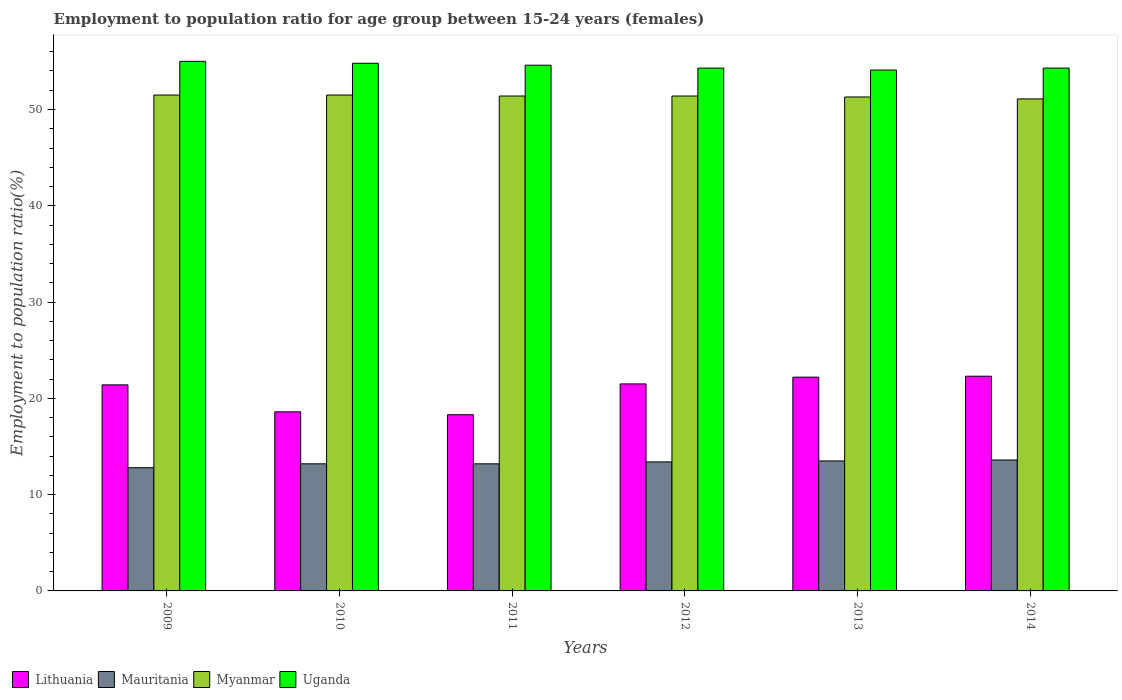How many groups of bars are there?
Make the answer very short. 6. Are the number of bars per tick equal to the number of legend labels?
Offer a terse response. Yes. Are the number of bars on each tick of the X-axis equal?
Your answer should be very brief. Yes. What is the employment to population ratio in Myanmar in 2013?
Keep it short and to the point. 51.3. Across all years, what is the maximum employment to population ratio in Myanmar?
Your response must be concise. 51.5. Across all years, what is the minimum employment to population ratio in Lithuania?
Offer a very short reply. 18.3. In which year was the employment to population ratio in Lithuania maximum?
Offer a very short reply. 2014. In which year was the employment to population ratio in Uganda minimum?
Keep it short and to the point. 2013. What is the total employment to population ratio in Uganda in the graph?
Offer a very short reply. 327.1. What is the difference between the employment to population ratio in Lithuania in 2010 and that in 2012?
Your response must be concise. -2.9. What is the difference between the employment to population ratio in Uganda in 2011 and the employment to population ratio in Myanmar in 2012?
Provide a short and direct response. 3.2. What is the average employment to population ratio in Myanmar per year?
Give a very brief answer. 51.37. In the year 2014, what is the difference between the employment to population ratio in Mauritania and employment to population ratio in Myanmar?
Keep it short and to the point. -37.5. What is the ratio of the employment to population ratio in Uganda in 2010 to that in 2011?
Make the answer very short. 1. Is the employment to population ratio in Lithuania in 2009 less than that in 2010?
Your answer should be very brief. No. Is the difference between the employment to population ratio in Mauritania in 2011 and 2014 greater than the difference between the employment to population ratio in Myanmar in 2011 and 2014?
Ensure brevity in your answer.  No. What is the difference between the highest and the lowest employment to population ratio in Myanmar?
Your answer should be very brief. 0.4. In how many years, is the employment to population ratio in Uganda greater than the average employment to population ratio in Uganda taken over all years?
Give a very brief answer. 3. What does the 1st bar from the left in 2012 represents?
Give a very brief answer. Lithuania. What does the 2nd bar from the right in 2010 represents?
Keep it short and to the point. Myanmar. How many bars are there?
Your answer should be compact. 24. What is the difference between two consecutive major ticks on the Y-axis?
Make the answer very short. 10. Does the graph contain any zero values?
Your answer should be compact. No. Where does the legend appear in the graph?
Make the answer very short. Bottom left. How many legend labels are there?
Make the answer very short. 4. How are the legend labels stacked?
Ensure brevity in your answer.  Horizontal. What is the title of the graph?
Your answer should be very brief. Employment to population ratio for age group between 15-24 years (females). What is the Employment to population ratio(%) of Lithuania in 2009?
Your answer should be very brief. 21.4. What is the Employment to population ratio(%) in Mauritania in 2009?
Make the answer very short. 12.8. What is the Employment to population ratio(%) in Myanmar in 2009?
Your answer should be compact. 51.5. What is the Employment to population ratio(%) of Uganda in 2009?
Ensure brevity in your answer.  55. What is the Employment to population ratio(%) in Lithuania in 2010?
Your response must be concise. 18.6. What is the Employment to population ratio(%) of Mauritania in 2010?
Keep it short and to the point. 13.2. What is the Employment to population ratio(%) in Myanmar in 2010?
Provide a short and direct response. 51.5. What is the Employment to population ratio(%) in Uganda in 2010?
Give a very brief answer. 54.8. What is the Employment to population ratio(%) in Lithuania in 2011?
Make the answer very short. 18.3. What is the Employment to population ratio(%) in Mauritania in 2011?
Your answer should be compact. 13.2. What is the Employment to population ratio(%) of Myanmar in 2011?
Your answer should be compact. 51.4. What is the Employment to population ratio(%) in Uganda in 2011?
Your response must be concise. 54.6. What is the Employment to population ratio(%) in Mauritania in 2012?
Your answer should be compact. 13.4. What is the Employment to population ratio(%) of Myanmar in 2012?
Ensure brevity in your answer.  51.4. What is the Employment to population ratio(%) of Uganda in 2012?
Your answer should be very brief. 54.3. What is the Employment to population ratio(%) of Lithuania in 2013?
Make the answer very short. 22.2. What is the Employment to population ratio(%) of Mauritania in 2013?
Give a very brief answer. 13.5. What is the Employment to population ratio(%) in Myanmar in 2013?
Ensure brevity in your answer.  51.3. What is the Employment to population ratio(%) in Uganda in 2013?
Ensure brevity in your answer.  54.1. What is the Employment to population ratio(%) in Lithuania in 2014?
Your response must be concise. 22.3. What is the Employment to population ratio(%) of Mauritania in 2014?
Give a very brief answer. 13.6. What is the Employment to population ratio(%) in Myanmar in 2014?
Offer a very short reply. 51.1. What is the Employment to population ratio(%) of Uganda in 2014?
Your response must be concise. 54.3. Across all years, what is the maximum Employment to population ratio(%) in Lithuania?
Give a very brief answer. 22.3. Across all years, what is the maximum Employment to population ratio(%) in Mauritania?
Offer a very short reply. 13.6. Across all years, what is the maximum Employment to population ratio(%) of Myanmar?
Offer a terse response. 51.5. Across all years, what is the minimum Employment to population ratio(%) of Lithuania?
Ensure brevity in your answer.  18.3. Across all years, what is the minimum Employment to population ratio(%) of Mauritania?
Keep it short and to the point. 12.8. Across all years, what is the minimum Employment to population ratio(%) in Myanmar?
Offer a terse response. 51.1. Across all years, what is the minimum Employment to population ratio(%) of Uganda?
Ensure brevity in your answer.  54.1. What is the total Employment to population ratio(%) in Lithuania in the graph?
Offer a very short reply. 124.3. What is the total Employment to population ratio(%) in Mauritania in the graph?
Ensure brevity in your answer.  79.7. What is the total Employment to population ratio(%) of Myanmar in the graph?
Make the answer very short. 308.2. What is the total Employment to population ratio(%) in Uganda in the graph?
Keep it short and to the point. 327.1. What is the difference between the Employment to population ratio(%) of Lithuania in 2009 and that in 2010?
Provide a succinct answer. 2.8. What is the difference between the Employment to population ratio(%) in Mauritania in 2009 and that in 2010?
Your answer should be compact. -0.4. What is the difference between the Employment to population ratio(%) in Myanmar in 2009 and that in 2010?
Give a very brief answer. 0. What is the difference between the Employment to population ratio(%) of Uganda in 2009 and that in 2010?
Offer a terse response. 0.2. What is the difference between the Employment to population ratio(%) in Mauritania in 2009 and that in 2011?
Give a very brief answer. -0.4. What is the difference between the Employment to population ratio(%) of Myanmar in 2009 and that in 2011?
Your answer should be very brief. 0.1. What is the difference between the Employment to population ratio(%) of Lithuania in 2009 and that in 2012?
Offer a terse response. -0.1. What is the difference between the Employment to population ratio(%) of Mauritania in 2009 and that in 2013?
Ensure brevity in your answer.  -0.7. What is the difference between the Employment to population ratio(%) in Myanmar in 2009 and that in 2013?
Keep it short and to the point. 0.2. What is the difference between the Employment to population ratio(%) of Uganda in 2009 and that in 2013?
Ensure brevity in your answer.  0.9. What is the difference between the Employment to population ratio(%) of Lithuania in 2009 and that in 2014?
Give a very brief answer. -0.9. What is the difference between the Employment to population ratio(%) of Mauritania in 2009 and that in 2014?
Your response must be concise. -0.8. What is the difference between the Employment to population ratio(%) of Lithuania in 2010 and that in 2011?
Keep it short and to the point. 0.3. What is the difference between the Employment to population ratio(%) of Mauritania in 2010 and that in 2011?
Your response must be concise. 0. What is the difference between the Employment to population ratio(%) in Lithuania in 2010 and that in 2012?
Your answer should be very brief. -2.9. What is the difference between the Employment to population ratio(%) in Uganda in 2010 and that in 2012?
Your answer should be compact. 0.5. What is the difference between the Employment to population ratio(%) in Lithuania in 2010 and that in 2014?
Your response must be concise. -3.7. What is the difference between the Employment to population ratio(%) in Myanmar in 2010 and that in 2014?
Offer a very short reply. 0.4. What is the difference between the Employment to population ratio(%) of Uganda in 2010 and that in 2014?
Offer a very short reply. 0.5. What is the difference between the Employment to population ratio(%) of Mauritania in 2011 and that in 2012?
Your answer should be compact. -0.2. What is the difference between the Employment to population ratio(%) in Myanmar in 2011 and that in 2012?
Keep it short and to the point. 0. What is the difference between the Employment to population ratio(%) in Uganda in 2011 and that in 2012?
Offer a very short reply. 0.3. What is the difference between the Employment to population ratio(%) in Mauritania in 2011 and that in 2013?
Provide a succinct answer. -0.3. What is the difference between the Employment to population ratio(%) of Myanmar in 2011 and that in 2013?
Your answer should be very brief. 0.1. What is the difference between the Employment to population ratio(%) in Uganda in 2011 and that in 2013?
Provide a short and direct response. 0.5. What is the difference between the Employment to population ratio(%) in Lithuania in 2011 and that in 2014?
Your answer should be compact. -4. What is the difference between the Employment to population ratio(%) of Mauritania in 2011 and that in 2014?
Give a very brief answer. -0.4. What is the difference between the Employment to population ratio(%) in Mauritania in 2012 and that in 2013?
Offer a terse response. -0.1. What is the difference between the Employment to population ratio(%) in Myanmar in 2012 and that in 2013?
Keep it short and to the point. 0.1. What is the difference between the Employment to population ratio(%) in Lithuania in 2012 and that in 2014?
Ensure brevity in your answer.  -0.8. What is the difference between the Employment to population ratio(%) in Uganda in 2012 and that in 2014?
Provide a short and direct response. 0. What is the difference between the Employment to population ratio(%) in Lithuania in 2013 and that in 2014?
Your response must be concise. -0.1. What is the difference between the Employment to population ratio(%) of Mauritania in 2013 and that in 2014?
Offer a very short reply. -0.1. What is the difference between the Employment to population ratio(%) of Myanmar in 2013 and that in 2014?
Your answer should be compact. 0.2. What is the difference between the Employment to population ratio(%) in Uganda in 2013 and that in 2014?
Your response must be concise. -0.2. What is the difference between the Employment to population ratio(%) of Lithuania in 2009 and the Employment to population ratio(%) of Mauritania in 2010?
Provide a succinct answer. 8.2. What is the difference between the Employment to population ratio(%) in Lithuania in 2009 and the Employment to population ratio(%) in Myanmar in 2010?
Provide a short and direct response. -30.1. What is the difference between the Employment to population ratio(%) in Lithuania in 2009 and the Employment to population ratio(%) in Uganda in 2010?
Provide a succinct answer. -33.4. What is the difference between the Employment to population ratio(%) of Mauritania in 2009 and the Employment to population ratio(%) of Myanmar in 2010?
Your answer should be compact. -38.7. What is the difference between the Employment to population ratio(%) of Mauritania in 2009 and the Employment to population ratio(%) of Uganda in 2010?
Make the answer very short. -42. What is the difference between the Employment to population ratio(%) of Myanmar in 2009 and the Employment to population ratio(%) of Uganda in 2010?
Your answer should be very brief. -3.3. What is the difference between the Employment to population ratio(%) in Lithuania in 2009 and the Employment to population ratio(%) in Myanmar in 2011?
Provide a short and direct response. -30. What is the difference between the Employment to population ratio(%) of Lithuania in 2009 and the Employment to population ratio(%) of Uganda in 2011?
Give a very brief answer. -33.2. What is the difference between the Employment to population ratio(%) in Mauritania in 2009 and the Employment to population ratio(%) in Myanmar in 2011?
Your answer should be very brief. -38.6. What is the difference between the Employment to population ratio(%) of Mauritania in 2009 and the Employment to population ratio(%) of Uganda in 2011?
Keep it short and to the point. -41.8. What is the difference between the Employment to population ratio(%) of Lithuania in 2009 and the Employment to population ratio(%) of Mauritania in 2012?
Ensure brevity in your answer.  8. What is the difference between the Employment to population ratio(%) in Lithuania in 2009 and the Employment to population ratio(%) in Myanmar in 2012?
Provide a succinct answer. -30. What is the difference between the Employment to population ratio(%) in Lithuania in 2009 and the Employment to population ratio(%) in Uganda in 2012?
Your answer should be very brief. -32.9. What is the difference between the Employment to population ratio(%) of Mauritania in 2009 and the Employment to population ratio(%) of Myanmar in 2012?
Your answer should be compact. -38.6. What is the difference between the Employment to population ratio(%) of Mauritania in 2009 and the Employment to population ratio(%) of Uganda in 2012?
Your response must be concise. -41.5. What is the difference between the Employment to population ratio(%) in Lithuania in 2009 and the Employment to population ratio(%) in Mauritania in 2013?
Make the answer very short. 7.9. What is the difference between the Employment to population ratio(%) in Lithuania in 2009 and the Employment to population ratio(%) in Myanmar in 2013?
Keep it short and to the point. -29.9. What is the difference between the Employment to population ratio(%) of Lithuania in 2009 and the Employment to population ratio(%) of Uganda in 2013?
Offer a very short reply. -32.7. What is the difference between the Employment to population ratio(%) in Mauritania in 2009 and the Employment to population ratio(%) in Myanmar in 2013?
Your response must be concise. -38.5. What is the difference between the Employment to population ratio(%) in Mauritania in 2009 and the Employment to population ratio(%) in Uganda in 2013?
Ensure brevity in your answer.  -41.3. What is the difference between the Employment to population ratio(%) of Lithuania in 2009 and the Employment to population ratio(%) of Myanmar in 2014?
Provide a short and direct response. -29.7. What is the difference between the Employment to population ratio(%) of Lithuania in 2009 and the Employment to population ratio(%) of Uganda in 2014?
Provide a succinct answer. -32.9. What is the difference between the Employment to population ratio(%) in Mauritania in 2009 and the Employment to population ratio(%) in Myanmar in 2014?
Your response must be concise. -38.3. What is the difference between the Employment to population ratio(%) in Mauritania in 2009 and the Employment to population ratio(%) in Uganda in 2014?
Offer a very short reply. -41.5. What is the difference between the Employment to population ratio(%) in Myanmar in 2009 and the Employment to population ratio(%) in Uganda in 2014?
Make the answer very short. -2.8. What is the difference between the Employment to population ratio(%) in Lithuania in 2010 and the Employment to population ratio(%) in Myanmar in 2011?
Offer a terse response. -32.8. What is the difference between the Employment to population ratio(%) of Lithuania in 2010 and the Employment to population ratio(%) of Uganda in 2011?
Your answer should be compact. -36. What is the difference between the Employment to population ratio(%) in Mauritania in 2010 and the Employment to population ratio(%) in Myanmar in 2011?
Offer a very short reply. -38.2. What is the difference between the Employment to population ratio(%) in Mauritania in 2010 and the Employment to population ratio(%) in Uganda in 2011?
Give a very brief answer. -41.4. What is the difference between the Employment to population ratio(%) of Myanmar in 2010 and the Employment to population ratio(%) of Uganda in 2011?
Your answer should be compact. -3.1. What is the difference between the Employment to population ratio(%) of Lithuania in 2010 and the Employment to population ratio(%) of Myanmar in 2012?
Offer a very short reply. -32.8. What is the difference between the Employment to population ratio(%) in Lithuania in 2010 and the Employment to population ratio(%) in Uganda in 2012?
Offer a terse response. -35.7. What is the difference between the Employment to population ratio(%) of Mauritania in 2010 and the Employment to population ratio(%) of Myanmar in 2012?
Offer a terse response. -38.2. What is the difference between the Employment to population ratio(%) of Mauritania in 2010 and the Employment to population ratio(%) of Uganda in 2012?
Give a very brief answer. -41.1. What is the difference between the Employment to population ratio(%) of Myanmar in 2010 and the Employment to population ratio(%) of Uganda in 2012?
Give a very brief answer. -2.8. What is the difference between the Employment to population ratio(%) of Lithuania in 2010 and the Employment to population ratio(%) of Myanmar in 2013?
Provide a succinct answer. -32.7. What is the difference between the Employment to population ratio(%) of Lithuania in 2010 and the Employment to population ratio(%) of Uganda in 2013?
Provide a succinct answer. -35.5. What is the difference between the Employment to population ratio(%) of Mauritania in 2010 and the Employment to population ratio(%) of Myanmar in 2013?
Offer a very short reply. -38.1. What is the difference between the Employment to population ratio(%) of Mauritania in 2010 and the Employment to population ratio(%) of Uganda in 2013?
Give a very brief answer. -40.9. What is the difference between the Employment to population ratio(%) in Myanmar in 2010 and the Employment to population ratio(%) in Uganda in 2013?
Ensure brevity in your answer.  -2.6. What is the difference between the Employment to population ratio(%) of Lithuania in 2010 and the Employment to population ratio(%) of Mauritania in 2014?
Offer a terse response. 5. What is the difference between the Employment to population ratio(%) in Lithuania in 2010 and the Employment to population ratio(%) in Myanmar in 2014?
Provide a succinct answer. -32.5. What is the difference between the Employment to population ratio(%) of Lithuania in 2010 and the Employment to population ratio(%) of Uganda in 2014?
Your response must be concise. -35.7. What is the difference between the Employment to population ratio(%) of Mauritania in 2010 and the Employment to population ratio(%) of Myanmar in 2014?
Your answer should be compact. -37.9. What is the difference between the Employment to population ratio(%) of Mauritania in 2010 and the Employment to population ratio(%) of Uganda in 2014?
Provide a succinct answer. -41.1. What is the difference between the Employment to population ratio(%) in Myanmar in 2010 and the Employment to population ratio(%) in Uganda in 2014?
Your answer should be very brief. -2.8. What is the difference between the Employment to population ratio(%) in Lithuania in 2011 and the Employment to population ratio(%) in Myanmar in 2012?
Make the answer very short. -33.1. What is the difference between the Employment to population ratio(%) in Lithuania in 2011 and the Employment to population ratio(%) in Uganda in 2012?
Your response must be concise. -36. What is the difference between the Employment to population ratio(%) in Mauritania in 2011 and the Employment to population ratio(%) in Myanmar in 2012?
Keep it short and to the point. -38.2. What is the difference between the Employment to population ratio(%) of Mauritania in 2011 and the Employment to population ratio(%) of Uganda in 2012?
Provide a succinct answer. -41.1. What is the difference between the Employment to population ratio(%) of Myanmar in 2011 and the Employment to population ratio(%) of Uganda in 2012?
Provide a succinct answer. -2.9. What is the difference between the Employment to population ratio(%) in Lithuania in 2011 and the Employment to population ratio(%) in Mauritania in 2013?
Provide a succinct answer. 4.8. What is the difference between the Employment to population ratio(%) in Lithuania in 2011 and the Employment to population ratio(%) in Myanmar in 2013?
Provide a short and direct response. -33. What is the difference between the Employment to population ratio(%) of Lithuania in 2011 and the Employment to population ratio(%) of Uganda in 2013?
Make the answer very short. -35.8. What is the difference between the Employment to population ratio(%) of Mauritania in 2011 and the Employment to population ratio(%) of Myanmar in 2013?
Ensure brevity in your answer.  -38.1. What is the difference between the Employment to population ratio(%) in Mauritania in 2011 and the Employment to population ratio(%) in Uganda in 2013?
Your answer should be compact. -40.9. What is the difference between the Employment to population ratio(%) of Myanmar in 2011 and the Employment to population ratio(%) of Uganda in 2013?
Ensure brevity in your answer.  -2.7. What is the difference between the Employment to population ratio(%) of Lithuania in 2011 and the Employment to population ratio(%) of Mauritania in 2014?
Your answer should be very brief. 4.7. What is the difference between the Employment to population ratio(%) in Lithuania in 2011 and the Employment to population ratio(%) in Myanmar in 2014?
Make the answer very short. -32.8. What is the difference between the Employment to population ratio(%) of Lithuania in 2011 and the Employment to population ratio(%) of Uganda in 2014?
Provide a succinct answer. -36. What is the difference between the Employment to population ratio(%) in Mauritania in 2011 and the Employment to population ratio(%) in Myanmar in 2014?
Give a very brief answer. -37.9. What is the difference between the Employment to population ratio(%) in Mauritania in 2011 and the Employment to population ratio(%) in Uganda in 2014?
Make the answer very short. -41.1. What is the difference between the Employment to population ratio(%) in Myanmar in 2011 and the Employment to population ratio(%) in Uganda in 2014?
Make the answer very short. -2.9. What is the difference between the Employment to population ratio(%) of Lithuania in 2012 and the Employment to population ratio(%) of Mauritania in 2013?
Offer a very short reply. 8. What is the difference between the Employment to population ratio(%) in Lithuania in 2012 and the Employment to population ratio(%) in Myanmar in 2013?
Offer a very short reply. -29.8. What is the difference between the Employment to population ratio(%) of Lithuania in 2012 and the Employment to population ratio(%) of Uganda in 2013?
Your response must be concise. -32.6. What is the difference between the Employment to population ratio(%) of Mauritania in 2012 and the Employment to population ratio(%) of Myanmar in 2013?
Provide a short and direct response. -37.9. What is the difference between the Employment to population ratio(%) of Mauritania in 2012 and the Employment to population ratio(%) of Uganda in 2013?
Your answer should be very brief. -40.7. What is the difference between the Employment to population ratio(%) in Lithuania in 2012 and the Employment to population ratio(%) in Mauritania in 2014?
Offer a very short reply. 7.9. What is the difference between the Employment to population ratio(%) in Lithuania in 2012 and the Employment to population ratio(%) in Myanmar in 2014?
Provide a short and direct response. -29.6. What is the difference between the Employment to population ratio(%) of Lithuania in 2012 and the Employment to population ratio(%) of Uganda in 2014?
Provide a short and direct response. -32.8. What is the difference between the Employment to population ratio(%) in Mauritania in 2012 and the Employment to population ratio(%) in Myanmar in 2014?
Provide a succinct answer. -37.7. What is the difference between the Employment to population ratio(%) in Mauritania in 2012 and the Employment to population ratio(%) in Uganda in 2014?
Ensure brevity in your answer.  -40.9. What is the difference between the Employment to population ratio(%) of Lithuania in 2013 and the Employment to population ratio(%) of Mauritania in 2014?
Provide a short and direct response. 8.6. What is the difference between the Employment to population ratio(%) in Lithuania in 2013 and the Employment to population ratio(%) in Myanmar in 2014?
Give a very brief answer. -28.9. What is the difference between the Employment to population ratio(%) of Lithuania in 2013 and the Employment to population ratio(%) of Uganda in 2014?
Make the answer very short. -32.1. What is the difference between the Employment to population ratio(%) of Mauritania in 2013 and the Employment to population ratio(%) of Myanmar in 2014?
Offer a terse response. -37.6. What is the difference between the Employment to population ratio(%) of Mauritania in 2013 and the Employment to population ratio(%) of Uganda in 2014?
Your answer should be compact. -40.8. What is the average Employment to population ratio(%) of Lithuania per year?
Keep it short and to the point. 20.72. What is the average Employment to population ratio(%) in Mauritania per year?
Your answer should be compact. 13.28. What is the average Employment to population ratio(%) of Myanmar per year?
Give a very brief answer. 51.37. What is the average Employment to population ratio(%) of Uganda per year?
Your answer should be very brief. 54.52. In the year 2009, what is the difference between the Employment to population ratio(%) in Lithuania and Employment to population ratio(%) in Myanmar?
Make the answer very short. -30.1. In the year 2009, what is the difference between the Employment to population ratio(%) of Lithuania and Employment to population ratio(%) of Uganda?
Offer a very short reply. -33.6. In the year 2009, what is the difference between the Employment to population ratio(%) of Mauritania and Employment to population ratio(%) of Myanmar?
Your response must be concise. -38.7. In the year 2009, what is the difference between the Employment to population ratio(%) of Mauritania and Employment to population ratio(%) of Uganda?
Your answer should be very brief. -42.2. In the year 2009, what is the difference between the Employment to population ratio(%) in Myanmar and Employment to population ratio(%) in Uganda?
Provide a short and direct response. -3.5. In the year 2010, what is the difference between the Employment to population ratio(%) of Lithuania and Employment to population ratio(%) of Mauritania?
Offer a terse response. 5.4. In the year 2010, what is the difference between the Employment to population ratio(%) of Lithuania and Employment to population ratio(%) of Myanmar?
Ensure brevity in your answer.  -32.9. In the year 2010, what is the difference between the Employment to population ratio(%) in Lithuania and Employment to population ratio(%) in Uganda?
Your answer should be very brief. -36.2. In the year 2010, what is the difference between the Employment to population ratio(%) of Mauritania and Employment to population ratio(%) of Myanmar?
Your answer should be compact. -38.3. In the year 2010, what is the difference between the Employment to population ratio(%) in Mauritania and Employment to population ratio(%) in Uganda?
Offer a very short reply. -41.6. In the year 2011, what is the difference between the Employment to population ratio(%) in Lithuania and Employment to population ratio(%) in Myanmar?
Offer a terse response. -33.1. In the year 2011, what is the difference between the Employment to population ratio(%) of Lithuania and Employment to population ratio(%) of Uganda?
Your answer should be compact. -36.3. In the year 2011, what is the difference between the Employment to population ratio(%) of Mauritania and Employment to population ratio(%) of Myanmar?
Provide a short and direct response. -38.2. In the year 2011, what is the difference between the Employment to population ratio(%) in Mauritania and Employment to population ratio(%) in Uganda?
Provide a short and direct response. -41.4. In the year 2012, what is the difference between the Employment to population ratio(%) of Lithuania and Employment to population ratio(%) of Mauritania?
Keep it short and to the point. 8.1. In the year 2012, what is the difference between the Employment to population ratio(%) of Lithuania and Employment to population ratio(%) of Myanmar?
Your response must be concise. -29.9. In the year 2012, what is the difference between the Employment to population ratio(%) of Lithuania and Employment to population ratio(%) of Uganda?
Your answer should be compact. -32.8. In the year 2012, what is the difference between the Employment to population ratio(%) in Mauritania and Employment to population ratio(%) in Myanmar?
Provide a short and direct response. -38. In the year 2012, what is the difference between the Employment to population ratio(%) in Mauritania and Employment to population ratio(%) in Uganda?
Offer a very short reply. -40.9. In the year 2013, what is the difference between the Employment to population ratio(%) in Lithuania and Employment to population ratio(%) in Mauritania?
Your response must be concise. 8.7. In the year 2013, what is the difference between the Employment to population ratio(%) of Lithuania and Employment to population ratio(%) of Myanmar?
Keep it short and to the point. -29.1. In the year 2013, what is the difference between the Employment to population ratio(%) of Lithuania and Employment to population ratio(%) of Uganda?
Provide a short and direct response. -31.9. In the year 2013, what is the difference between the Employment to population ratio(%) of Mauritania and Employment to population ratio(%) of Myanmar?
Provide a short and direct response. -37.8. In the year 2013, what is the difference between the Employment to population ratio(%) in Mauritania and Employment to population ratio(%) in Uganda?
Your answer should be very brief. -40.6. In the year 2013, what is the difference between the Employment to population ratio(%) of Myanmar and Employment to population ratio(%) of Uganda?
Give a very brief answer. -2.8. In the year 2014, what is the difference between the Employment to population ratio(%) of Lithuania and Employment to population ratio(%) of Myanmar?
Your answer should be compact. -28.8. In the year 2014, what is the difference between the Employment to population ratio(%) of Lithuania and Employment to population ratio(%) of Uganda?
Your answer should be compact. -32. In the year 2014, what is the difference between the Employment to population ratio(%) of Mauritania and Employment to population ratio(%) of Myanmar?
Offer a very short reply. -37.5. In the year 2014, what is the difference between the Employment to population ratio(%) of Mauritania and Employment to population ratio(%) of Uganda?
Give a very brief answer. -40.7. What is the ratio of the Employment to population ratio(%) of Lithuania in 2009 to that in 2010?
Offer a very short reply. 1.15. What is the ratio of the Employment to population ratio(%) of Mauritania in 2009 to that in 2010?
Provide a short and direct response. 0.97. What is the ratio of the Employment to population ratio(%) of Lithuania in 2009 to that in 2011?
Your answer should be very brief. 1.17. What is the ratio of the Employment to population ratio(%) of Mauritania in 2009 to that in 2011?
Make the answer very short. 0.97. What is the ratio of the Employment to population ratio(%) in Uganda in 2009 to that in 2011?
Offer a terse response. 1.01. What is the ratio of the Employment to population ratio(%) in Mauritania in 2009 to that in 2012?
Provide a succinct answer. 0.96. What is the ratio of the Employment to population ratio(%) of Uganda in 2009 to that in 2012?
Provide a short and direct response. 1.01. What is the ratio of the Employment to population ratio(%) of Lithuania in 2009 to that in 2013?
Offer a terse response. 0.96. What is the ratio of the Employment to population ratio(%) in Mauritania in 2009 to that in 2013?
Your response must be concise. 0.95. What is the ratio of the Employment to population ratio(%) in Uganda in 2009 to that in 2013?
Provide a succinct answer. 1.02. What is the ratio of the Employment to population ratio(%) in Lithuania in 2009 to that in 2014?
Your answer should be very brief. 0.96. What is the ratio of the Employment to population ratio(%) in Uganda in 2009 to that in 2014?
Make the answer very short. 1.01. What is the ratio of the Employment to population ratio(%) in Lithuania in 2010 to that in 2011?
Ensure brevity in your answer.  1.02. What is the ratio of the Employment to population ratio(%) of Mauritania in 2010 to that in 2011?
Give a very brief answer. 1. What is the ratio of the Employment to population ratio(%) of Myanmar in 2010 to that in 2011?
Give a very brief answer. 1. What is the ratio of the Employment to population ratio(%) of Uganda in 2010 to that in 2011?
Your response must be concise. 1. What is the ratio of the Employment to population ratio(%) of Lithuania in 2010 to that in 2012?
Make the answer very short. 0.87. What is the ratio of the Employment to population ratio(%) in Mauritania in 2010 to that in 2012?
Provide a succinct answer. 0.99. What is the ratio of the Employment to population ratio(%) in Myanmar in 2010 to that in 2012?
Provide a succinct answer. 1. What is the ratio of the Employment to population ratio(%) of Uganda in 2010 to that in 2012?
Your answer should be compact. 1.01. What is the ratio of the Employment to population ratio(%) in Lithuania in 2010 to that in 2013?
Your answer should be very brief. 0.84. What is the ratio of the Employment to population ratio(%) of Mauritania in 2010 to that in 2013?
Provide a short and direct response. 0.98. What is the ratio of the Employment to population ratio(%) in Uganda in 2010 to that in 2013?
Keep it short and to the point. 1.01. What is the ratio of the Employment to population ratio(%) of Lithuania in 2010 to that in 2014?
Provide a succinct answer. 0.83. What is the ratio of the Employment to population ratio(%) in Mauritania in 2010 to that in 2014?
Your answer should be very brief. 0.97. What is the ratio of the Employment to population ratio(%) of Myanmar in 2010 to that in 2014?
Your answer should be very brief. 1.01. What is the ratio of the Employment to population ratio(%) of Uganda in 2010 to that in 2014?
Provide a short and direct response. 1.01. What is the ratio of the Employment to population ratio(%) in Lithuania in 2011 to that in 2012?
Offer a terse response. 0.85. What is the ratio of the Employment to population ratio(%) of Mauritania in 2011 to that in 2012?
Provide a short and direct response. 0.99. What is the ratio of the Employment to population ratio(%) in Uganda in 2011 to that in 2012?
Offer a very short reply. 1.01. What is the ratio of the Employment to population ratio(%) of Lithuania in 2011 to that in 2013?
Offer a terse response. 0.82. What is the ratio of the Employment to population ratio(%) in Mauritania in 2011 to that in 2013?
Make the answer very short. 0.98. What is the ratio of the Employment to population ratio(%) in Uganda in 2011 to that in 2013?
Provide a short and direct response. 1.01. What is the ratio of the Employment to population ratio(%) of Lithuania in 2011 to that in 2014?
Your response must be concise. 0.82. What is the ratio of the Employment to population ratio(%) in Mauritania in 2011 to that in 2014?
Make the answer very short. 0.97. What is the ratio of the Employment to population ratio(%) in Myanmar in 2011 to that in 2014?
Your response must be concise. 1.01. What is the ratio of the Employment to population ratio(%) in Uganda in 2011 to that in 2014?
Offer a terse response. 1.01. What is the ratio of the Employment to population ratio(%) of Lithuania in 2012 to that in 2013?
Keep it short and to the point. 0.97. What is the ratio of the Employment to population ratio(%) in Mauritania in 2012 to that in 2013?
Keep it short and to the point. 0.99. What is the ratio of the Employment to population ratio(%) in Uganda in 2012 to that in 2013?
Provide a succinct answer. 1. What is the ratio of the Employment to population ratio(%) of Lithuania in 2012 to that in 2014?
Your answer should be compact. 0.96. What is the ratio of the Employment to population ratio(%) of Mauritania in 2012 to that in 2014?
Keep it short and to the point. 0.99. What is the ratio of the Employment to population ratio(%) in Myanmar in 2012 to that in 2014?
Your answer should be very brief. 1.01. What is the ratio of the Employment to population ratio(%) in Lithuania in 2013 to that in 2014?
Give a very brief answer. 1. What is the ratio of the Employment to population ratio(%) of Mauritania in 2013 to that in 2014?
Offer a terse response. 0.99. What is the ratio of the Employment to population ratio(%) in Myanmar in 2013 to that in 2014?
Your answer should be compact. 1. What is the ratio of the Employment to population ratio(%) in Uganda in 2013 to that in 2014?
Give a very brief answer. 1. What is the difference between the highest and the second highest Employment to population ratio(%) in Uganda?
Provide a short and direct response. 0.2. What is the difference between the highest and the lowest Employment to population ratio(%) of Lithuania?
Your answer should be compact. 4. What is the difference between the highest and the lowest Employment to population ratio(%) in Myanmar?
Provide a short and direct response. 0.4. What is the difference between the highest and the lowest Employment to population ratio(%) of Uganda?
Ensure brevity in your answer.  0.9. 